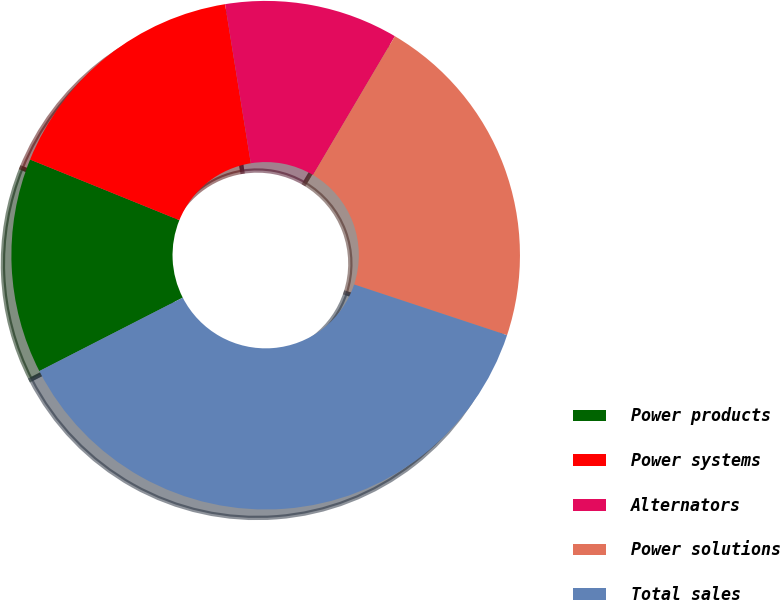<chart> <loc_0><loc_0><loc_500><loc_500><pie_chart><fcel>Power products<fcel>Power systems<fcel>Alternators<fcel>Power solutions<fcel>Total sales<nl><fcel>13.67%<fcel>16.31%<fcel>11.04%<fcel>21.61%<fcel>37.38%<nl></chart> 